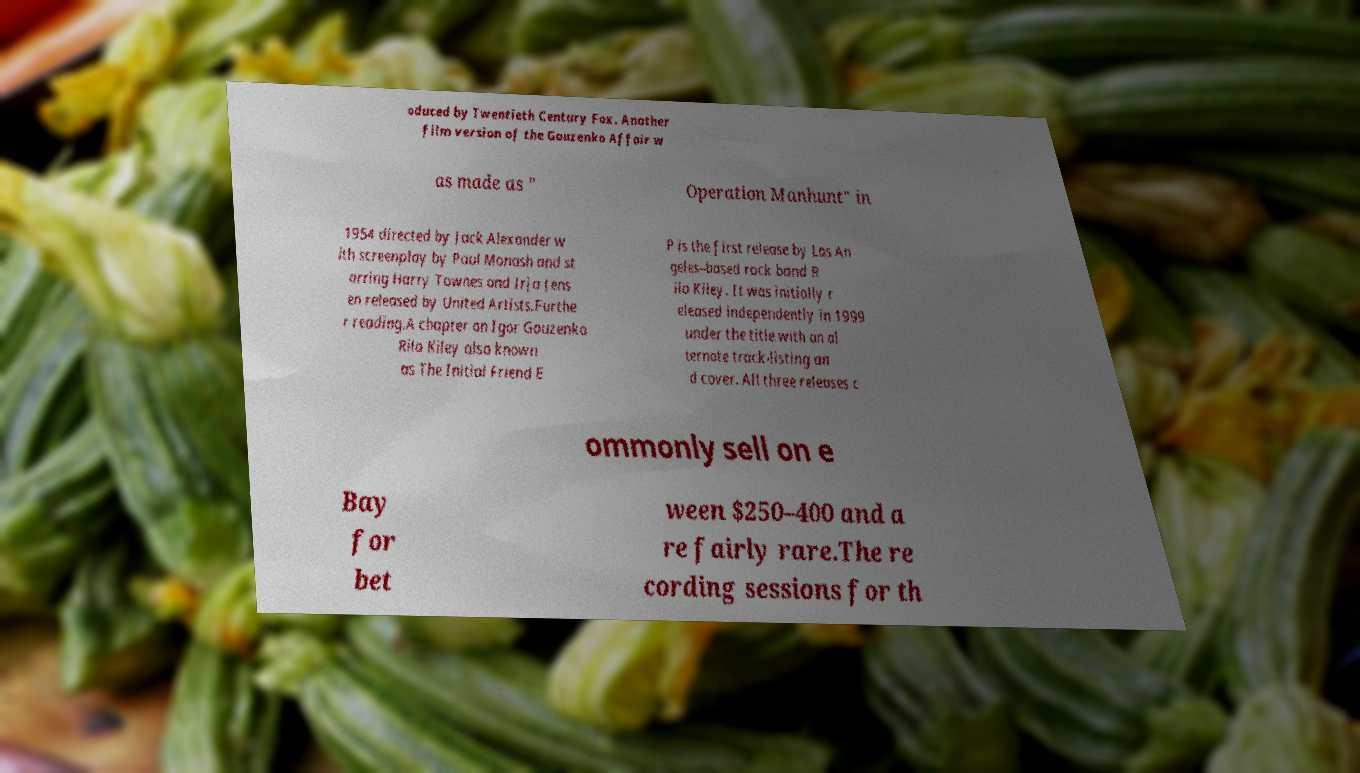Please read and relay the text visible in this image. What does it say? oduced by Twentieth Century Fox. Another film version of the Gouzenko Affair w as made as " Operation Manhunt" in 1954 directed by Jack Alexander w ith screenplay by Paul Monash and st arring Harry Townes and Irja Jens en released by United Artists.Furthe r reading.A chapter on Igor Gouzenko Rilo Kiley also known as The Initial Friend E P is the first release by Los An geles–based rock band R ilo Kiley. It was initially r eleased independently in 1999 under the title with an al ternate track-listing an d cover. All three releases c ommonly sell on e Bay for bet ween $250–400 and a re fairly rare.The re cording sessions for th 